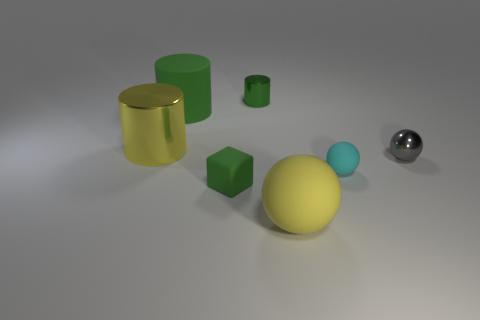Is the material of the cyan ball the same as the yellow object that is in front of the cyan matte thing?
Offer a terse response. Yes. There is a matte object that is the same color as the tiny matte block; what size is it?
Make the answer very short. Large. Are there any purple cubes that have the same material as the gray object?
Offer a terse response. No. How many objects are either rubber things right of the rubber block or green things that are on the left side of the tiny green cylinder?
Ensure brevity in your answer.  4. There is a cyan rubber object; is it the same shape as the small rubber object that is in front of the small cyan sphere?
Your answer should be compact. No. What number of other things are there of the same shape as the small cyan rubber thing?
Make the answer very short. 2. How many things are shiny objects or small yellow balls?
Provide a short and direct response. 3. Do the small rubber cube and the big rubber cylinder have the same color?
Keep it short and to the point. Yes. What shape is the big yellow object that is on the left side of the sphere in front of the green matte cube?
Ensure brevity in your answer.  Cylinder. Is the number of tiny green matte things less than the number of small blue matte spheres?
Your response must be concise. No. 